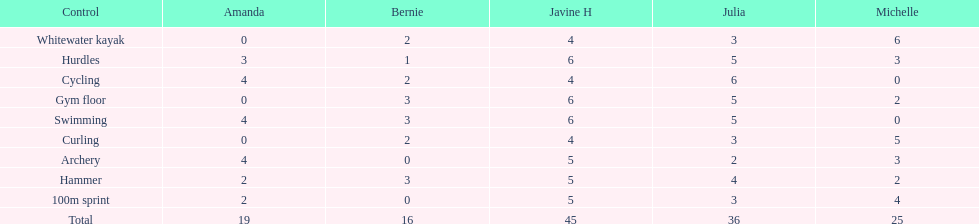What is the usual score for a 100m race? 2.8. 